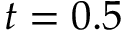<formula> <loc_0><loc_0><loc_500><loc_500>t = 0 . 5</formula> 